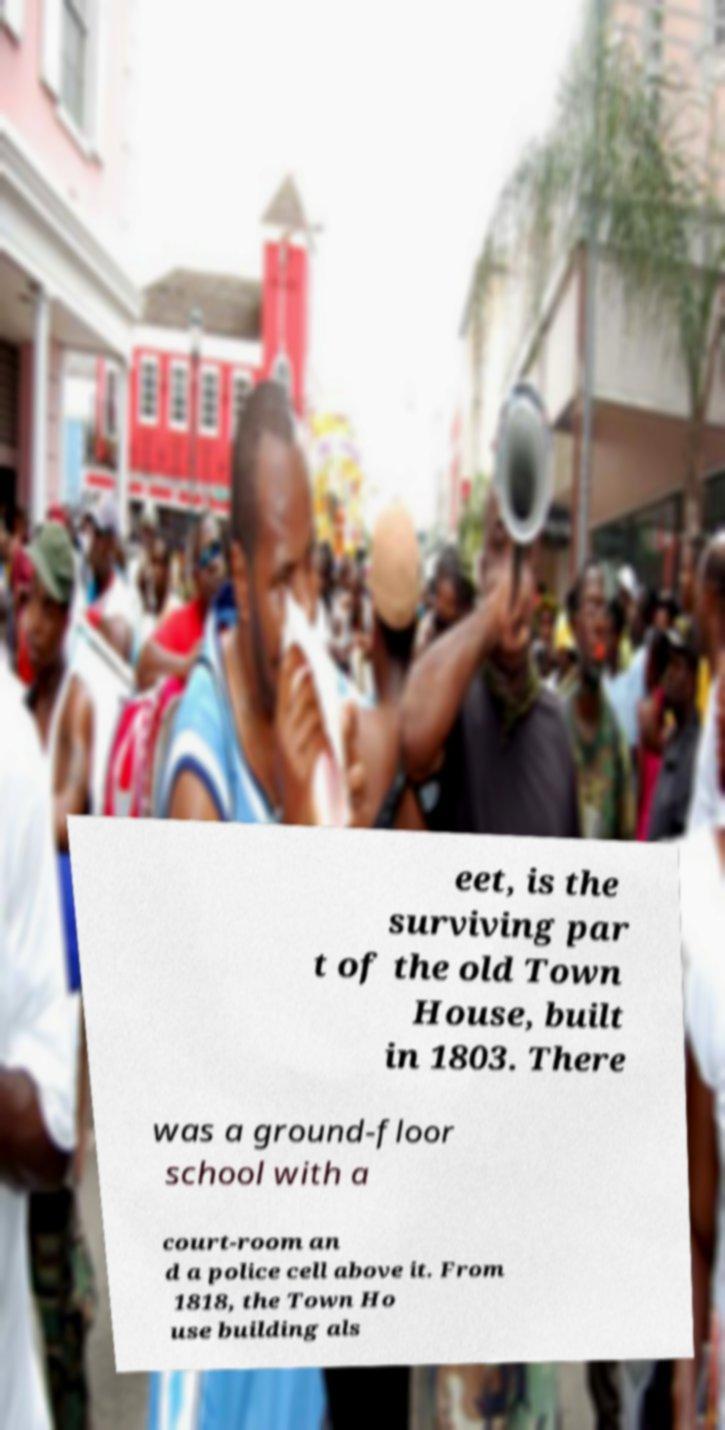Could you assist in decoding the text presented in this image and type it out clearly? eet, is the surviving par t of the old Town House, built in 1803. There was a ground-floor school with a court-room an d a police cell above it. From 1818, the Town Ho use building als 